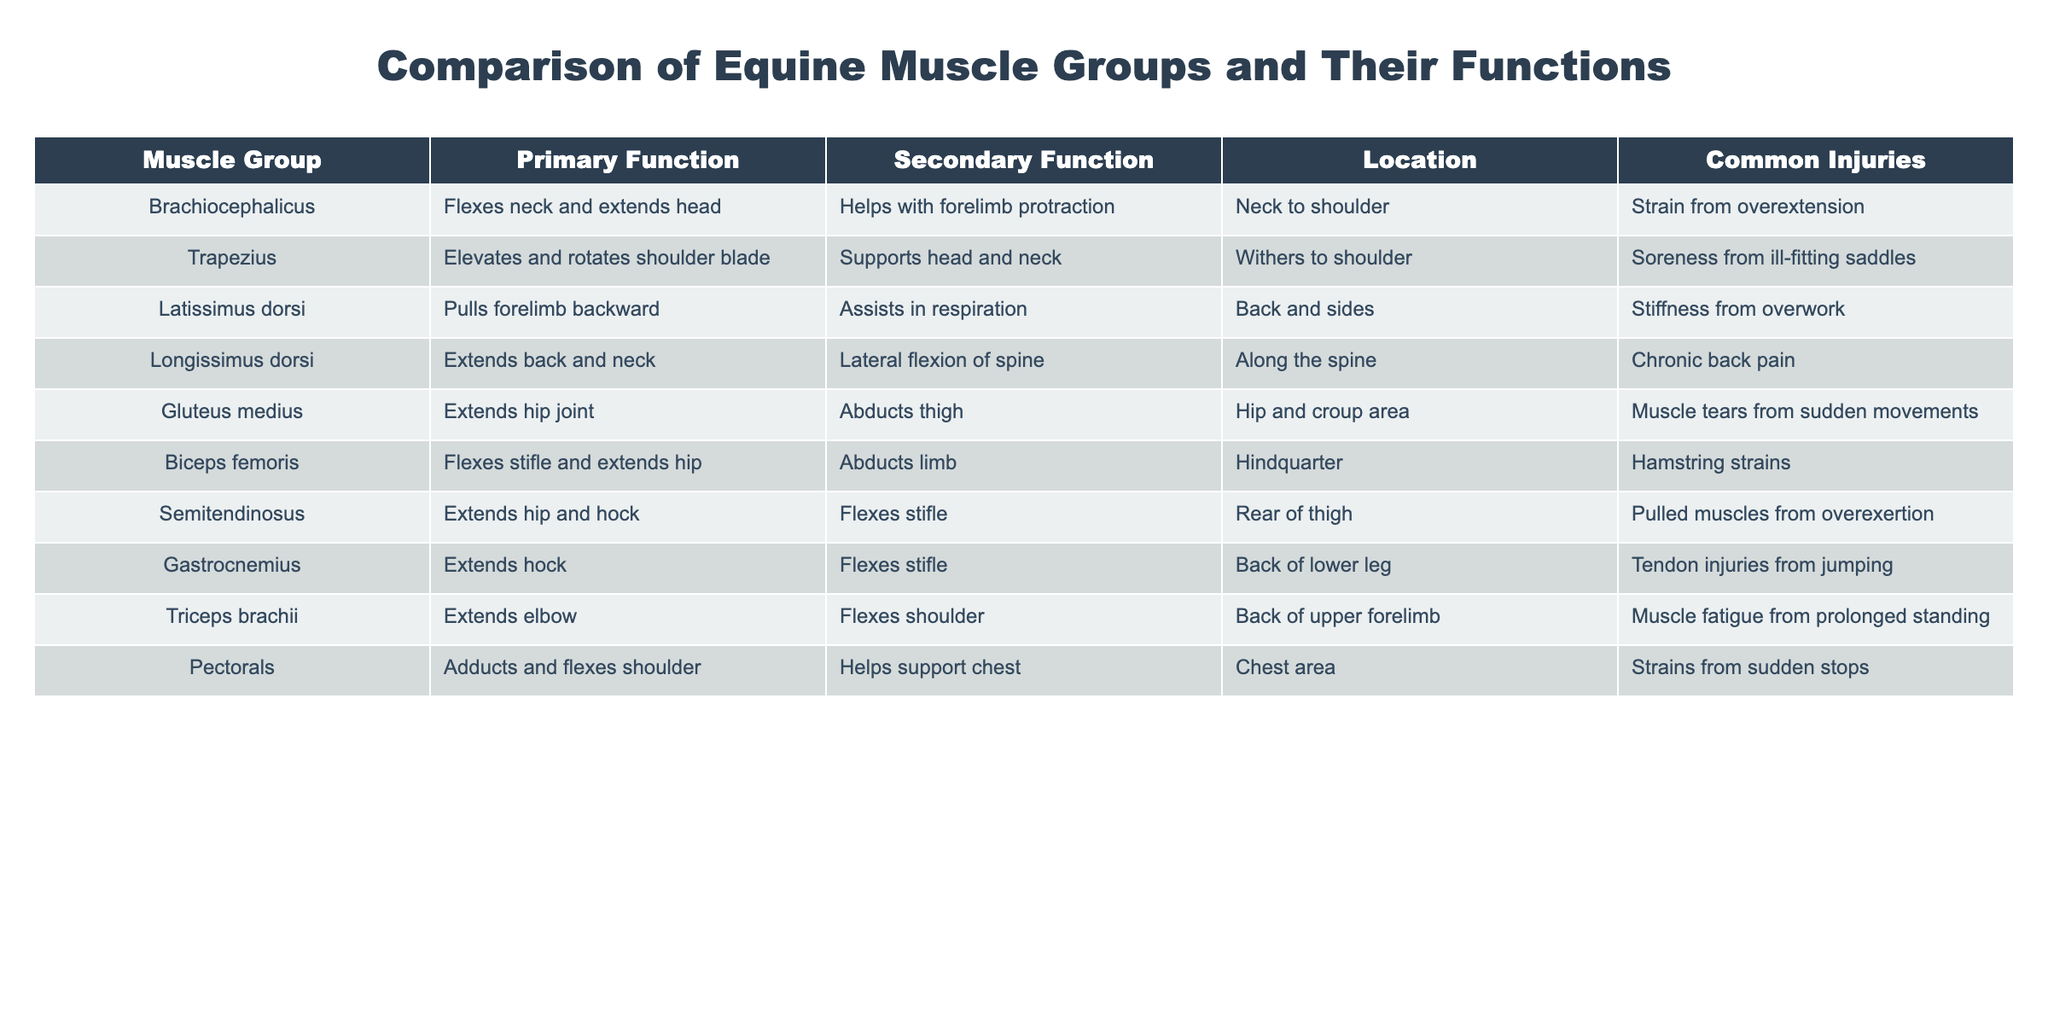What is the primary function of the Brachiocephalicus muscle group? The primary function of the Brachiocephalicus muscle group is to flex the neck and extend the head, as indicated in the table.
Answer: Flexes neck and extends head Which muscle group is responsible for pulling the forelimb backward? According to the table, the muscle group that pulls the forelimb backward is the Latissimus dorsi.
Answer: Latissimus dorsi Does the Gastrocnemius muscle group assist with flexing the stifle? Yes, the table indicates that the Gastrocnemius extends the hock and flexes the stifle, confirming this fact.
Answer: Yes What common injury is associated with the Gluteus medius? The common injury associated with the Gluteus medius, as per the table, is muscle tears from sudden movements.
Answer: Muscle tears from sudden movements List the primary functions of the Biceps femoris and Semitendinosus muscle groups. The primary function of the Biceps femoris is to flex the stifle and extend the hip, while the Semitendinosus extends the hip and hock, as stated in the table.
Answer: Flexes stifle and extends hip; Extends hip and hock Which muscle group has the most common injury related to jumping activities? The table shows that the Gastrocnemius muscle group is prone to tendon injuries from jumping, making it the answer.
Answer: Gastrocnemius What is the difference in primary functions between the Triceps brachii and Pectorals muscle groups? The Triceps brachii's primary function is to extend the elbow, while the Pectorals adduct and flex the shoulder, indicating their difference.
Answer: Extend elbow; Adducts and flexes shoulder How many muscle groups extend the hip joint? According to the table, both the Gluteus medius and Semitendinosus muscle groups extend the hip joint, giving a total of two.
Answer: Two Identify any muscle group that supports both respiration and forelimb movement. The Latissimus dorsi muscle group assists in respiration and pulls the forelimb backward, indicating it supports both functions.
Answer: Latissimus dorsi Is there a muscle group that exclusively flexes the neck? The table shows that the Brachiocephalicus flexes the neck but also extends the head, indicating it does not exclusively flex the neck.
Answer: No 